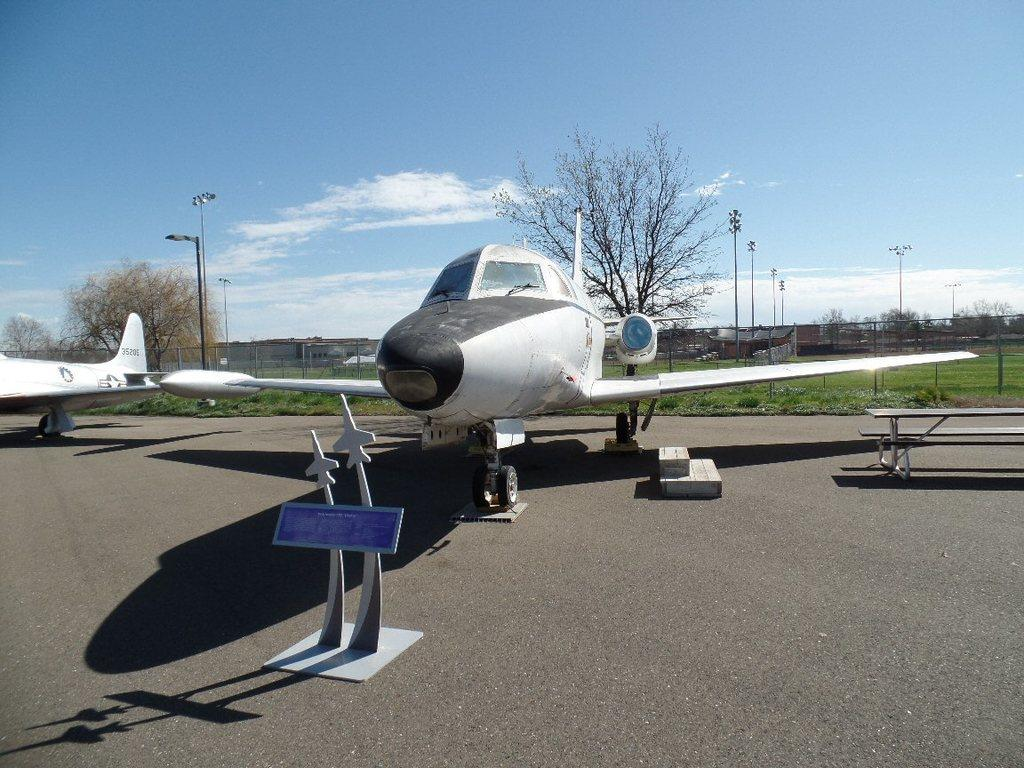What is the main subject of the image? The main subject of the image is an airplane. What color is the airplane? The airplane is white. Where is the airplane located in the image? The airplane is in the middle of the image. What can be seen in the background of the image? There are trees at the back side of the image, and the sky is visible at the top of the image. Can you tell me how many receipts are visible in the image? There are no receipts present in the image. Who is the friend that can be seen in the image? There is no friend visible in the image; it features an airplane. 